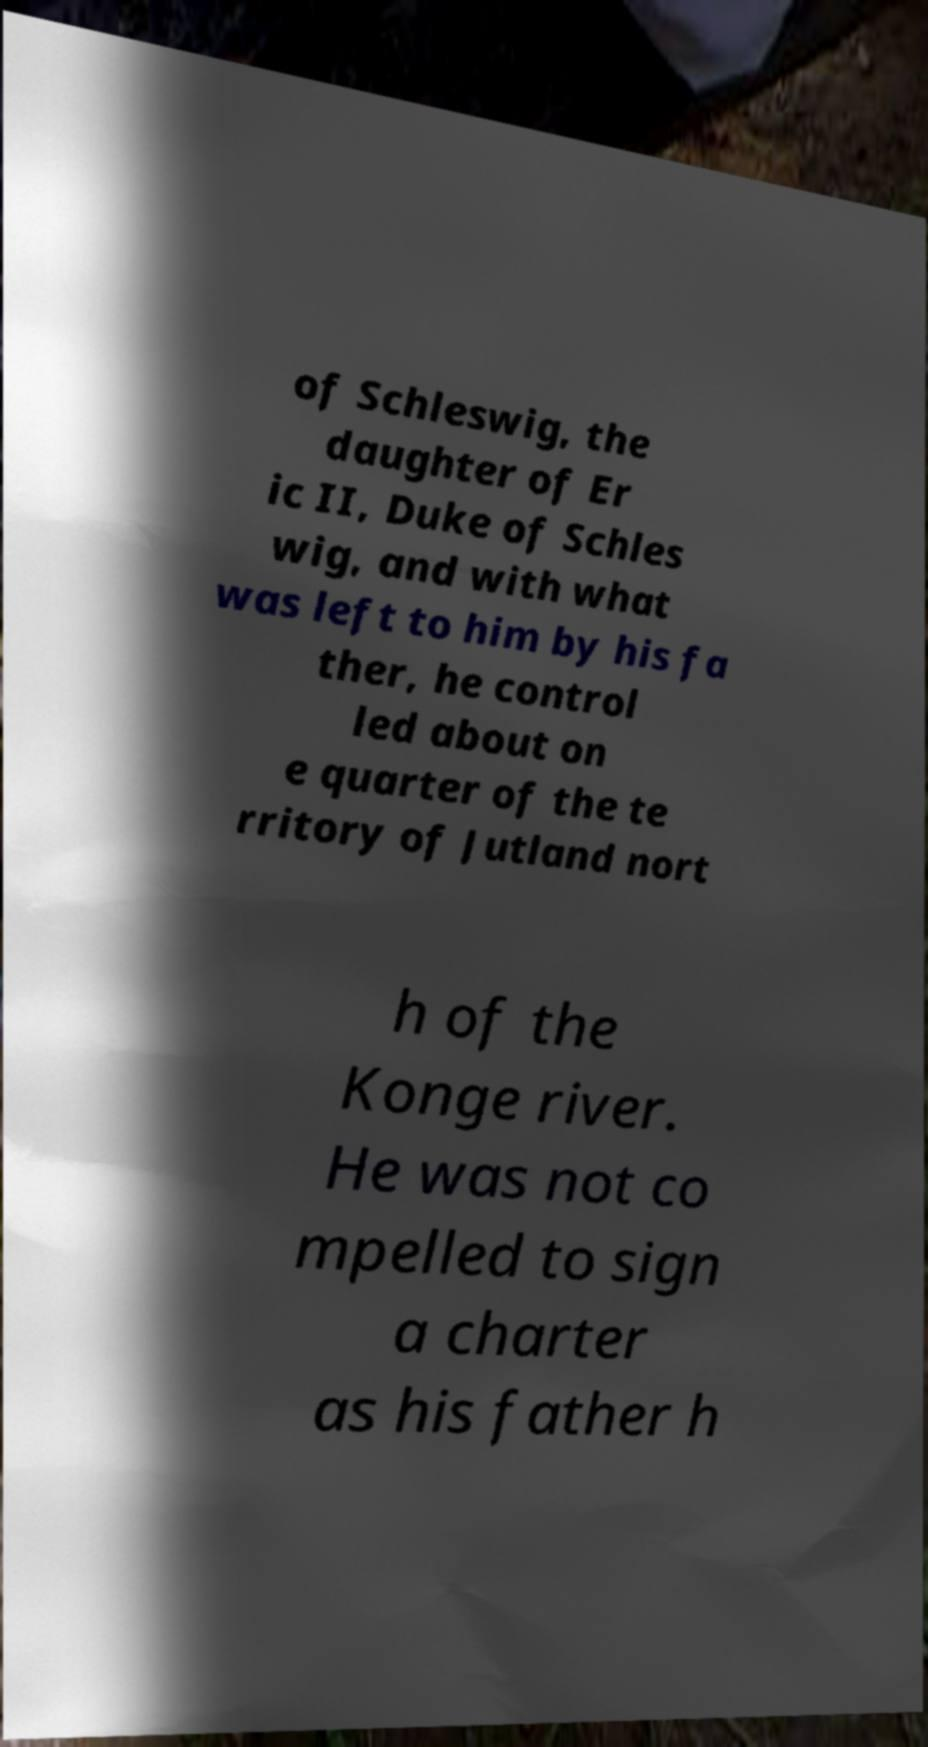Please identify and transcribe the text found in this image. of Schleswig, the daughter of Er ic II, Duke of Schles wig, and with what was left to him by his fa ther, he control led about on e quarter of the te rritory of Jutland nort h of the Konge river. He was not co mpelled to sign a charter as his father h 